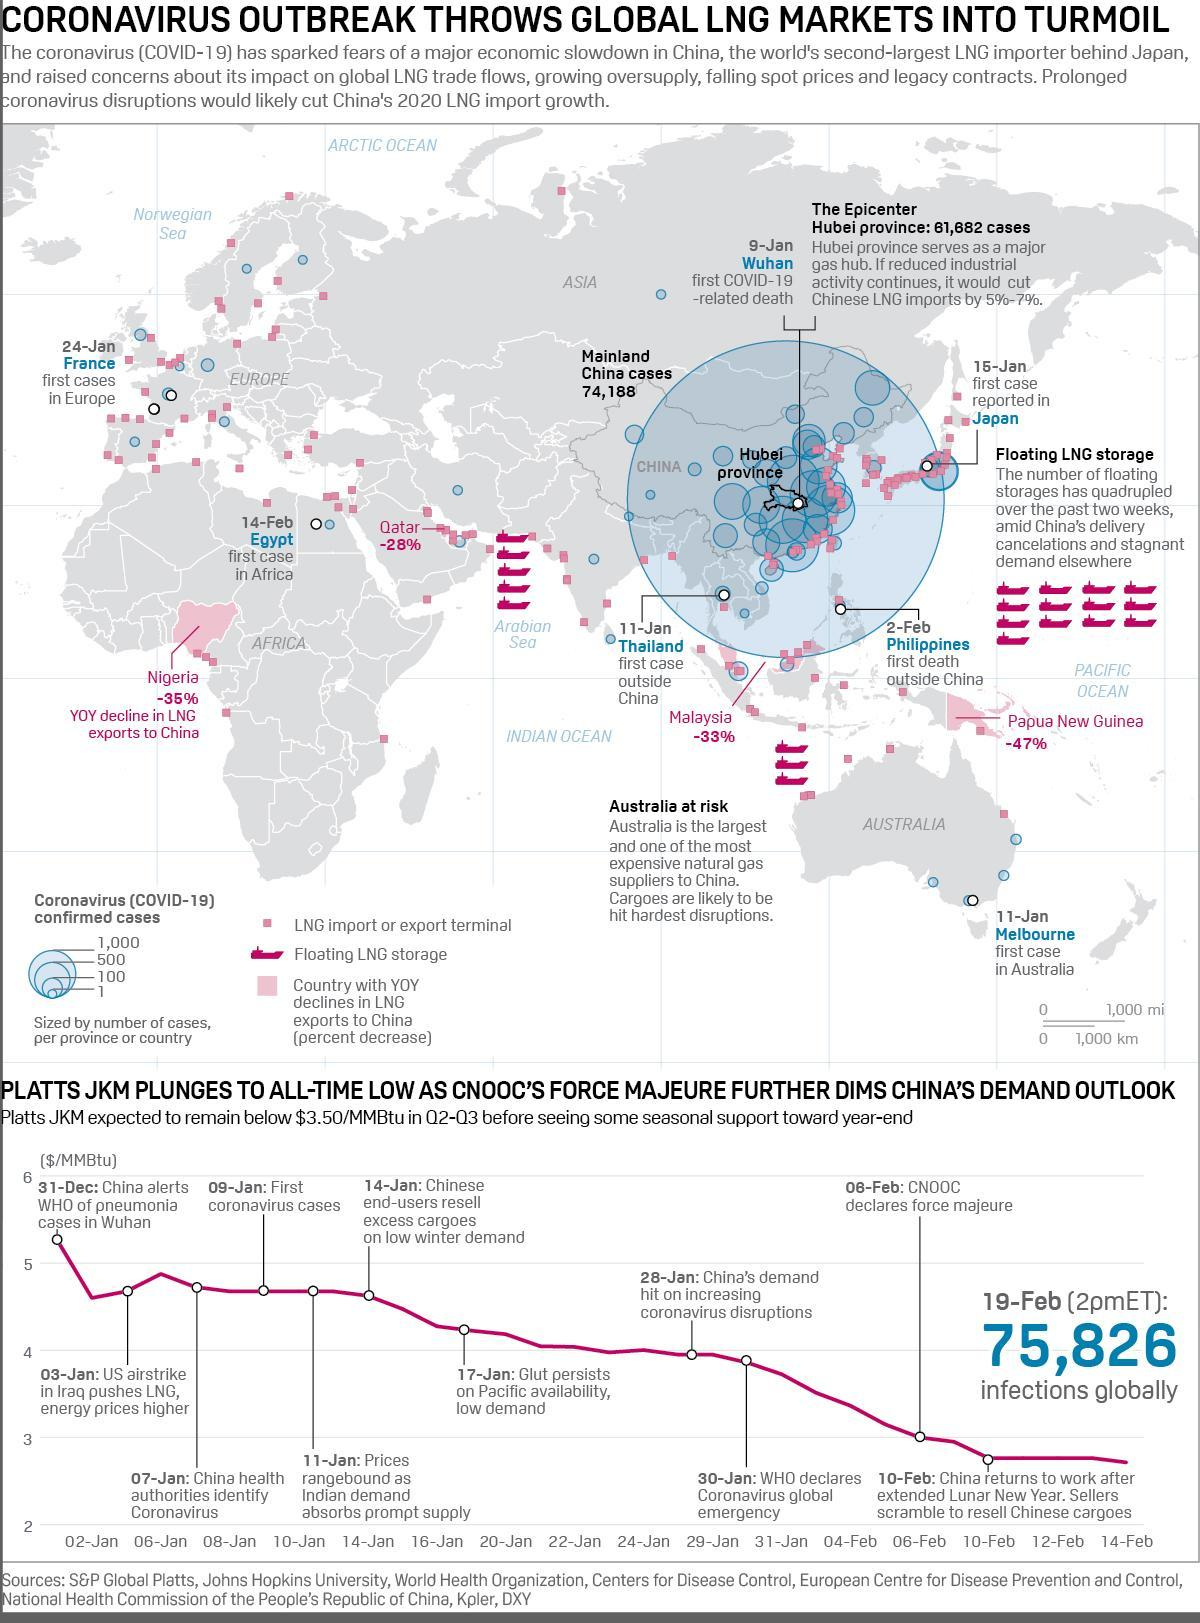What was the cause of the surge in the LNG prices?
Answer the question with a short phrase. US airstrike in Iraq When did the Chinese inform the World health organisation of pneumonia cases in Wuhan? 31-Dec When and where was the first case outside China reported? 11-Jan, Thailand What came first, US airstrike on Iraq ok or first coronavirus case? US airstrike on Iraq Which is an important gas hub of China? Hubei province When and by whom was force majeure declared? 08-Feb, CNOOC What came first, declaration of Global emergency or declaration of force majeure? Declaration of global emergency When did the Chinese first identify coronavirus? 07-Jan When and where was the first case in Europe reported? 24-Jan, France What were the number of cases in Mainland China? 74,188 Where was the first case in Africa reported? Egypt When and where was the first case in Australia reported? 11-Jan, Melbourne When was the first case reported in Japan? 15-Jan 